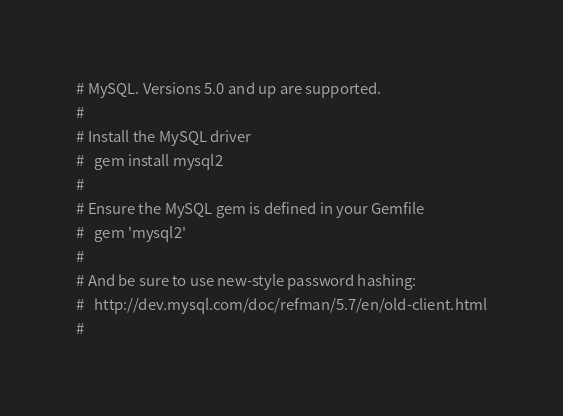<code> <loc_0><loc_0><loc_500><loc_500><_YAML_># MySQL. Versions 5.0 and up are supported.
#
# Install the MySQL driver
#   gem install mysql2
#
# Ensure the MySQL gem is defined in your Gemfile
#   gem 'mysql2'
#
# And be sure to use new-style password hashing:
#   http://dev.mysql.com/doc/refman/5.7/en/old-client.html
#</code> 